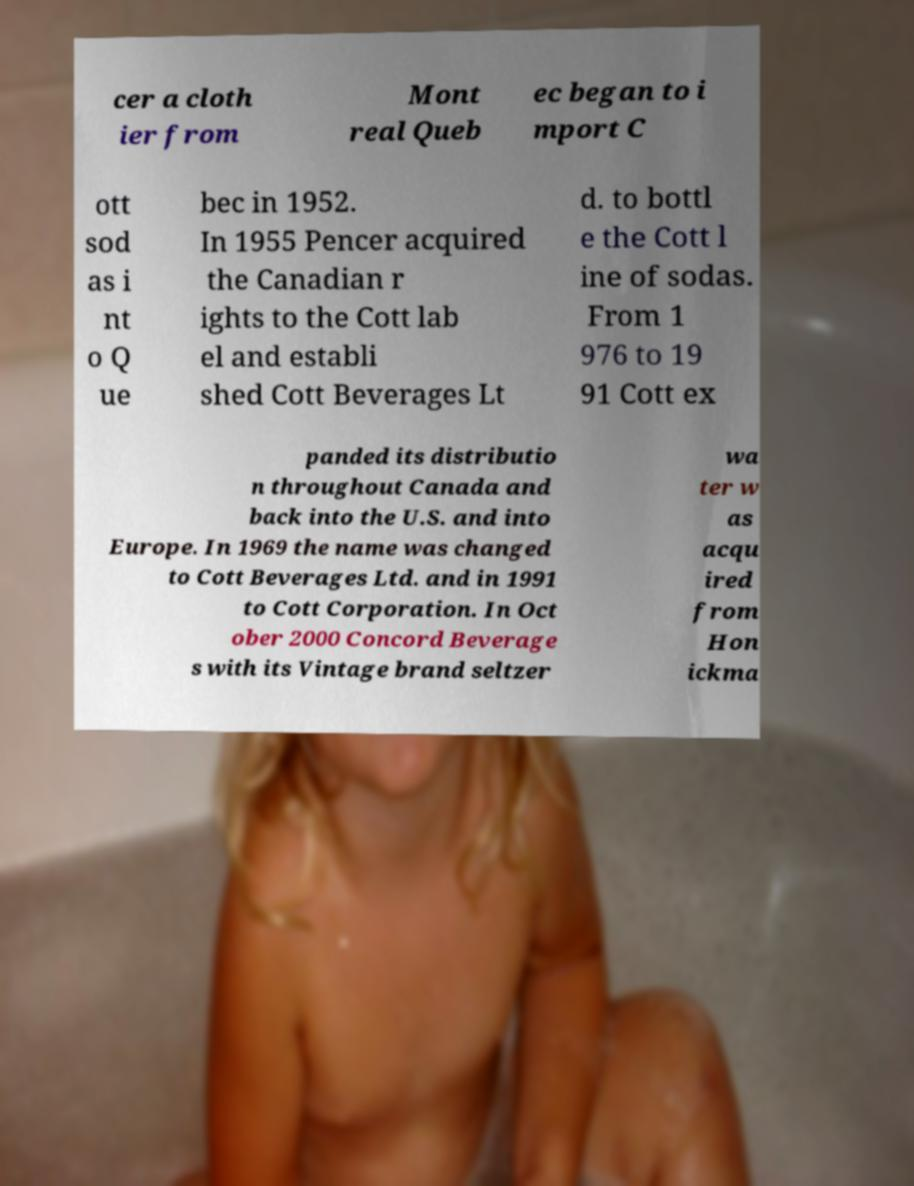Can you read and provide the text displayed in the image?This photo seems to have some interesting text. Can you extract and type it out for me? cer a cloth ier from Mont real Queb ec began to i mport C ott sod as i nt o Q ue bec in 1952. In 1955 Pencer acquired the Canadian r ights to the Cott lab el and establi shed Cott Beverages Lt d. to bottl e the Cott l ine of sodas. From 1 976 to 19 91 Cott ex panded its distributio n throughout Canada and back into the U.S. and into Europe. In 1969 the name was changed to Cott Beverages Ltd. and in 1991 to Cott Corporation. In Oct ober 2000 Concord Beverage s with its Vintage brand seltzer wa ter w as acqu ired from Hon ickma 